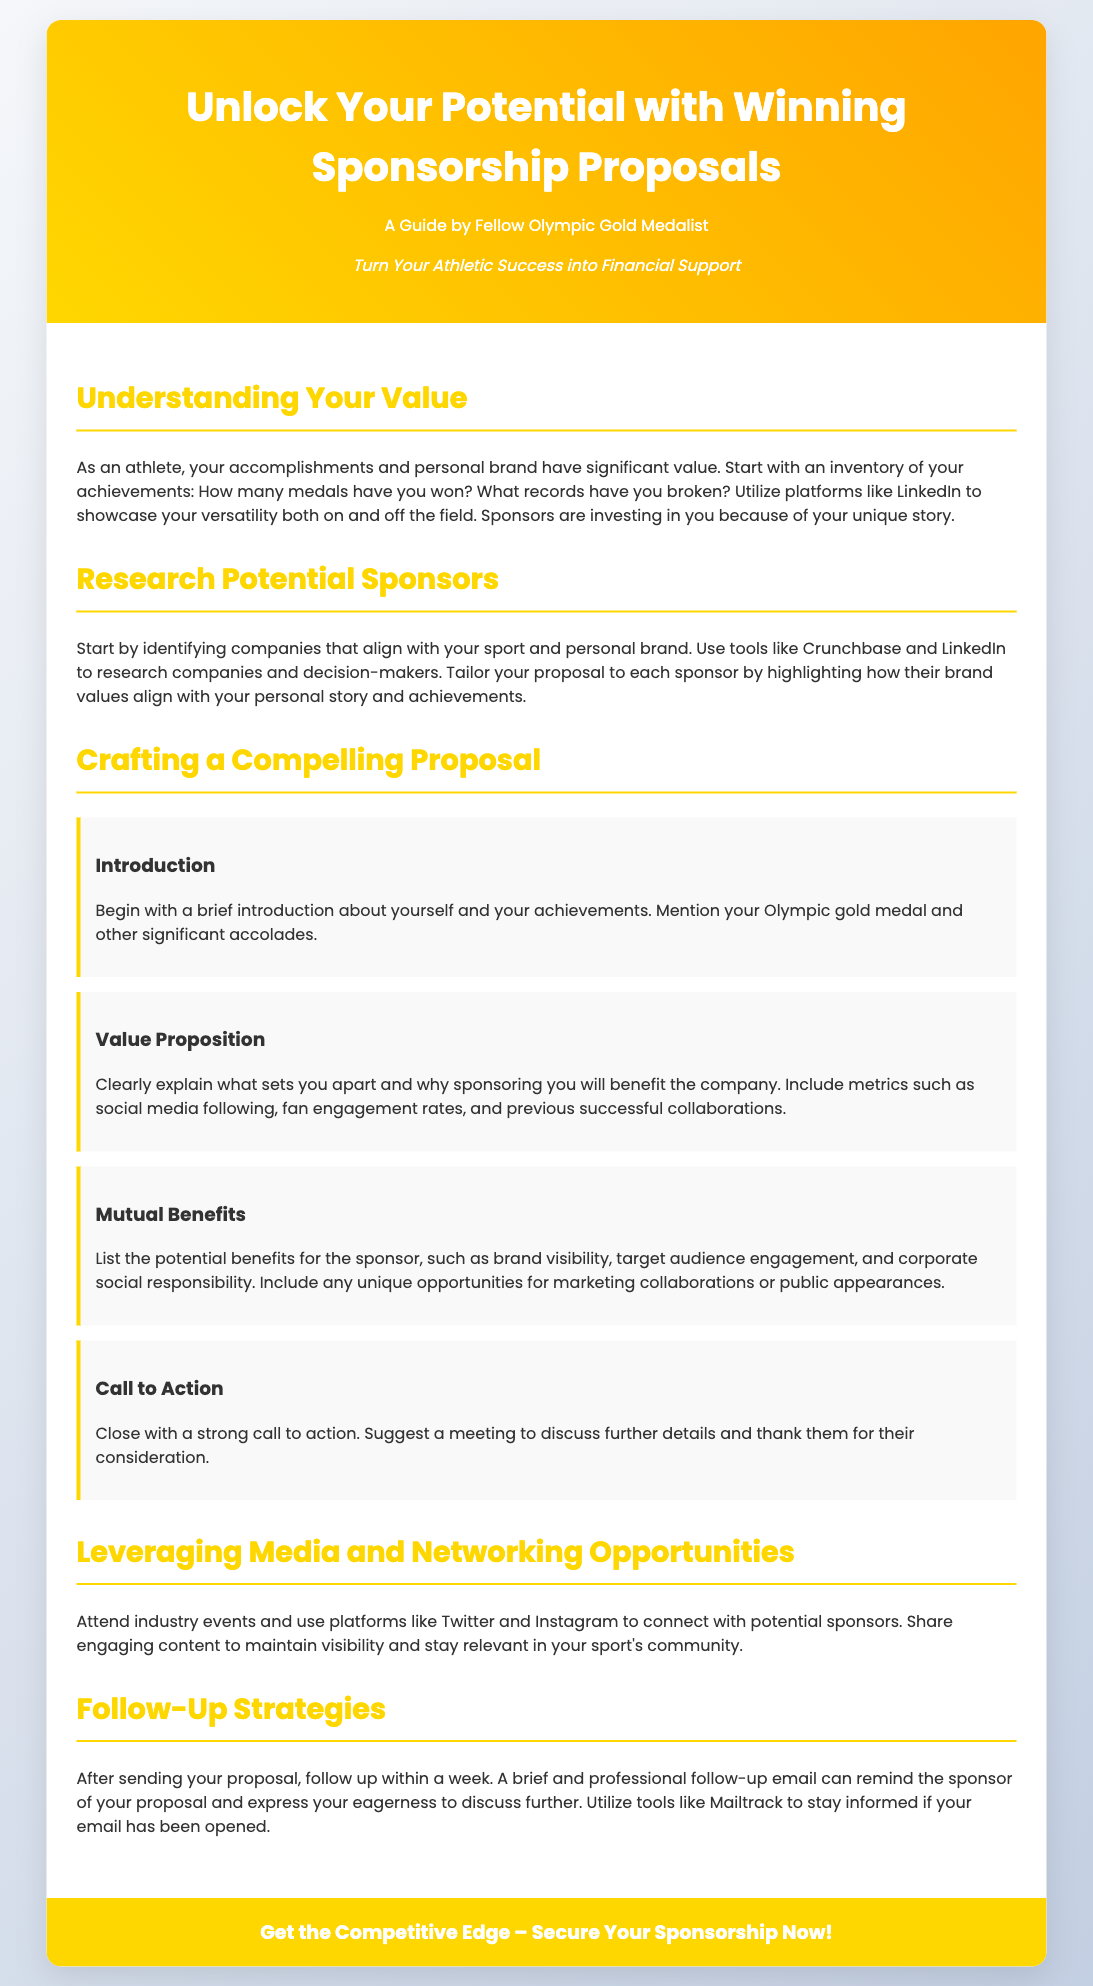What is the title of the guide? The title of the guide is mentioned at the top of the document.
Answer: Unlock Your Potential with Winning Sponsorship Proposals Who is the guide authored by? The author is identified in the introduction section of the document.
Answer: Fellow Olympic Gold Medalist What is one key component of your value proposition? The section on crafting a compelling proposal highlights what to include in the value proposition.
Answer: Metrics such as social media following What should you do after sending your proposal? The follow-up strategies section provides guidance on what to do once the proposal has been sent.
Answer: Follow up within a week What type of events should you attend to find sponsors? The document suggests certain activities that would help connect with potential sponsors.
Answer: Industry events What does the introduction section of a proposal include? The introduction section specifies what the beginning of a sponsorship proposal should include about the athlete.
Answer: Brief introduction about yourself and your achievements What colors are used in the header background? The colors specified in the CSS for the header background are part of the visual design elements of the document.
Answer: Gold and Orange What is the call to action presented in the document? The call to action is a prominent part of the advertisement and encourages engagement.
Answer: Get the Competitive Edge – Secure Your Sponsorship Now! 